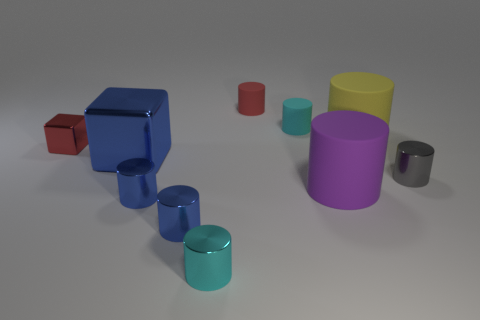Subtract all cyan rubber cylinders. How many cylinders are left? 7 Subtract all brown balls. How many cyan cylinders are left? 2 Subtract all purple cylinders. How many cylinders are left? 7 Subtract 7 cylinders. How many cylinders are left? 1 Subtract all large yellow rubber things. Subtract all small objects. How many objects are left? 2 Add 1 big yellow cylinders. How many big yellow cylinders are left? 2 Add 6 big cylinders. How many big cylinders exist? 8 Subtract 0 brown cubes. How many objects are left? 10 Subtract all cubes. How many objects are left? 8 Subtract all gray cubes. Subtract all red spheres. How many cubes are left? 2 